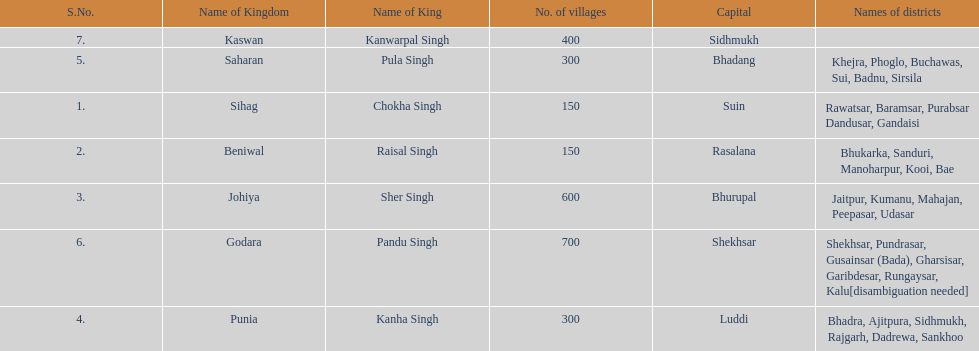What is the number of kingdoms that have more than 300 villages? 3. 